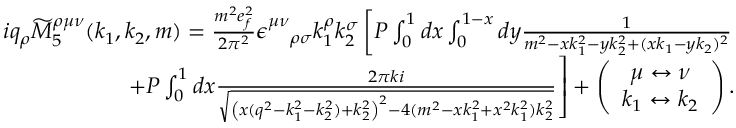Convert formula to latex. <formula><loc_0><loc_0><loc_500><loc_500>\begin{array} { r l r } & { i q _ { \rho } \widetilde { M } _ { 5 } ^ { \rho \mu \nu } ( k _ { 1 } , k _ { 2 } , m ) = \frac { m ^ { 2 } e _ { f } ^ { 2 } } { 2 \pi ^ { 2 } } \epsilon _ { \quad \rho \sigma } ^ { \mu \nu } k _ { 1 } ^ { \rho } k _ { 2 } ^ { \sigma } \left [ P \int _ { 0 } ^ { 1 } d x \int _ { 0 } ^ { 1 - x } d y \frac { 1 } { m ^ { 2 } - x k _ { 1 } ^ { 2 } - y k _ { 2 } ^ { 2 } + ( x k _ { 1 } - y k _ { 2 } ) ^ { 2 } } } \\ & { + P \int _ { 0 } ^ { 1 } d x \frac { 2 \pi k i } { \sqrt { \left ( x ( q ^ { 2 } - k _ { 1 } ^ { 2 } - k _ { 2 } ^ { 2 } ) + k _ { 2 } ^ { 2 } \right ) ^ { 2 } - 4 ( m ^ { 2 } - x k _ { 1 } ^ { 2 } + x ^ { 2 } k _ { 1 } ^ { 2 } ) k _ { 2 } ^ { 2 } } } \right ] + \left ( \begin{array} { c } { \mu \leftrightarrow \nu } \\ { k _ { 1 } \leftrightarrow k _ { 2 } } \end{array} \right ) . } \end{array}</formula> 